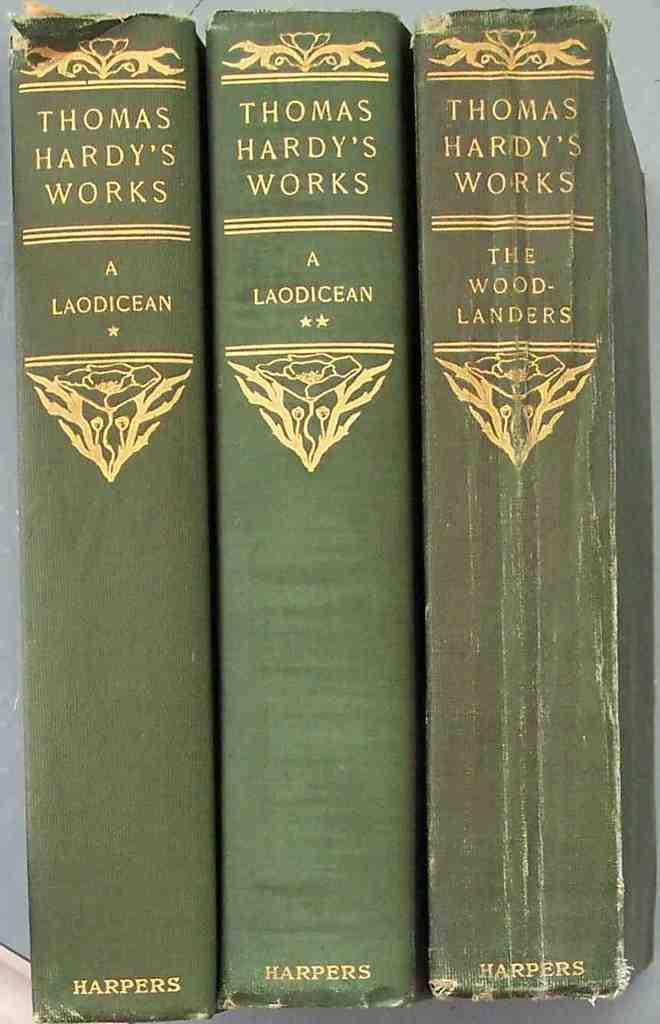<image>
Give a short and clear explanation of the subsequent image. Three volumes of books called Thomas Hardy Works. 